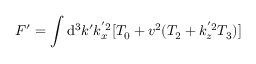Convert formula to latex. <formula><loc_0><loc_0><loc_500><loc_500>F ^ { \prime } = \int d ^ { 3 } k ^ { \prime } k _ { x } ^ { ^ { \prime } 2 } [ T _ { 0 } + v ^ { 2 } ( T _ { 2 } + k _ { z } ^ { ^ { \prime } 2 } T _ { 3 } ) ] \,</formula> 